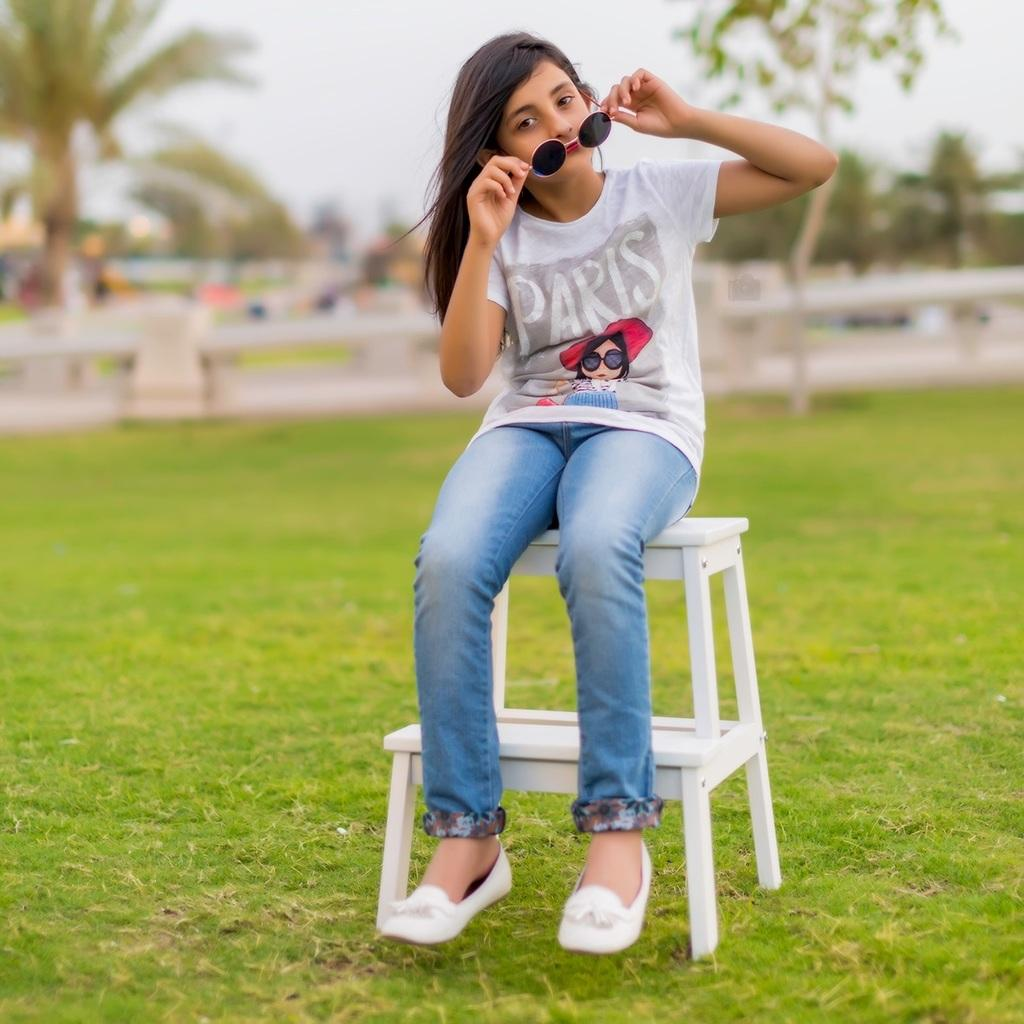What object is on the ground in the image? There is a stool on the ground in the image. What is the person in the image doing? The person is sitting on the stool in the image. What is the person holding in the image? The person is holding goggles in the image. Can you describe the background of the image? The background of the image is blurry. What time of day is it in the image, and how does the visitor interact with the person sitting on the stool? There is no mention of a visitor in the image, and the time of day cannot be determined from the provided facts. 